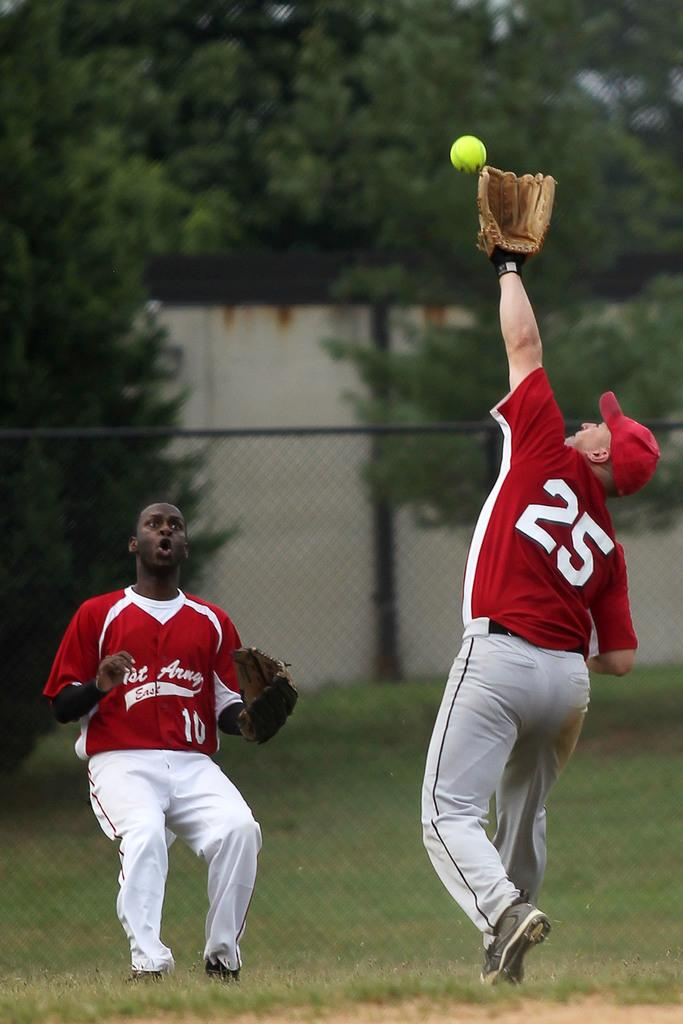<image>
Create a compact narrative representing the image presented. Two baseball players from first Army East while catching the ball 